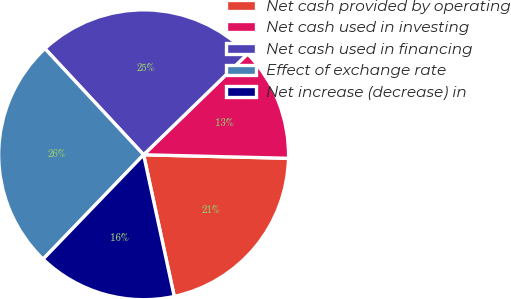Convert chart. <chart><loc_0><loc_0><loc_500><loc_500><pie_chart><fcel>Net cash provided by operating<fcel>Net cash used in investing<fcel>Net cash used in financing<fcel>Effect of exchange rate<fcel>Net increase (decrease) in<nl><fcel>21.22%<fcel>12.65%<fcel>24.66%<fcel>25.88%<fcel>15.59%<nl></chart> 